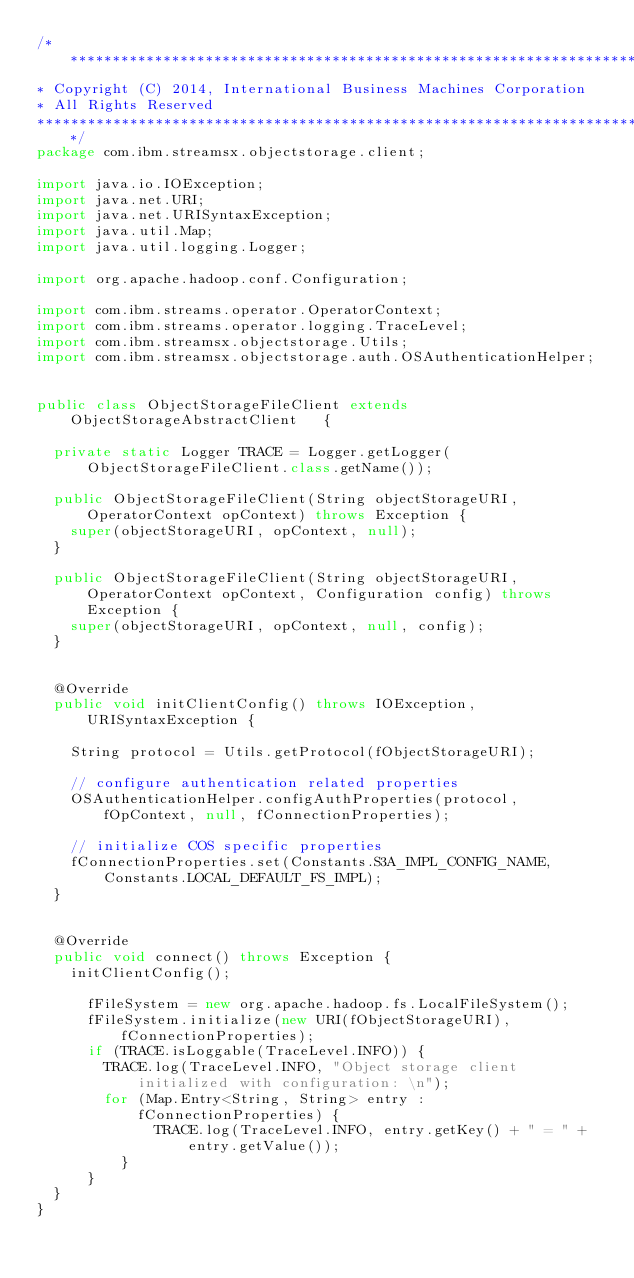Convert code to text. <code><loc_0><loc_0><loc_500><loc_500><_Java_>/*******************************************************************************
* Copyright (C) 2014, International Business Machines Corporation
* All Rights Reserved
*******************************************************************************/
package com.ibm.streamsx.objectstorage.client;

import java.io.IOException;
import java.net.URI;
import java.net.URISyntaxException;
import java.util.Map;
import java.util.logging.Logger;

import org.apache.hadoop.conf.Configuration;

import com.ibm.streams.operator.OperatorContext;
import com.ibm.streams.operator.logging.TraceLevel;
import com.ibm.streamsx.objectstorage.Utils;
import com.ibm.streamsx.objectstorage.auth.OSAuthenticationHelper;


public class ObjectStorageFileClient extends ObjectStorageAbstractClient   {

	private static Logger TRACE = Logger.getLogger(ObjectStorageFileClient.class.getName());

	public ObjectStorageFileClient(String objectStorageURI, OperatorContext opContext) throws Exception {
		super(objectStorageURI, opContext, null);
	}

	public ObjectStorageFileClient(String objectStorageURI, OperatorContext opContext, Configuration config) throws Exception {
		super(objectStorageURI, opContext, null, config);
	}
	
	
	@Override
	public void initClientConfig() throws IOException, URISyntaxException {

		String protocol = Utils.getProtocol(fObjectStorageURI);

		// configure authentication related properties
		OSAuthenticationHelper.configAuthProperties(protocol, fOpContext, null, fConnectionProperties);
		
		// initialize COS specific properties
		fConnectionProperties.set(Constants.S3A_IMPL_CONFIG_NAME, Constants.LOCAL_DEFAULT_FS_IMPL);
	}

	
	@Override
	public void connect() throws Exception {
		initClientConfig();
		
	    fFileSystem = new org.apache.hadoop.fs.LocalFileSystem();
	    fFileSystem.initialize(new URI(fObjectStorageURI), fConnectionProperties);	
	    if (TRACE.isLoggable(TraceLevel.INFO)) {
	    	TRACE.log(TraceLevel.INFO, "Object storage client initialized with configuration: \n");
	    	for (Map.Entry<String, String> entry : fConnectionProperties) {
            	TRACE.log(TraceLevel.INFO, entry.getKey() + " = " + entry.getValue());
        	}
	    }
	}
}
</code> 